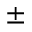<formula> <loc_0><loc_0><loc_500><loc_500>\pm</formula> 